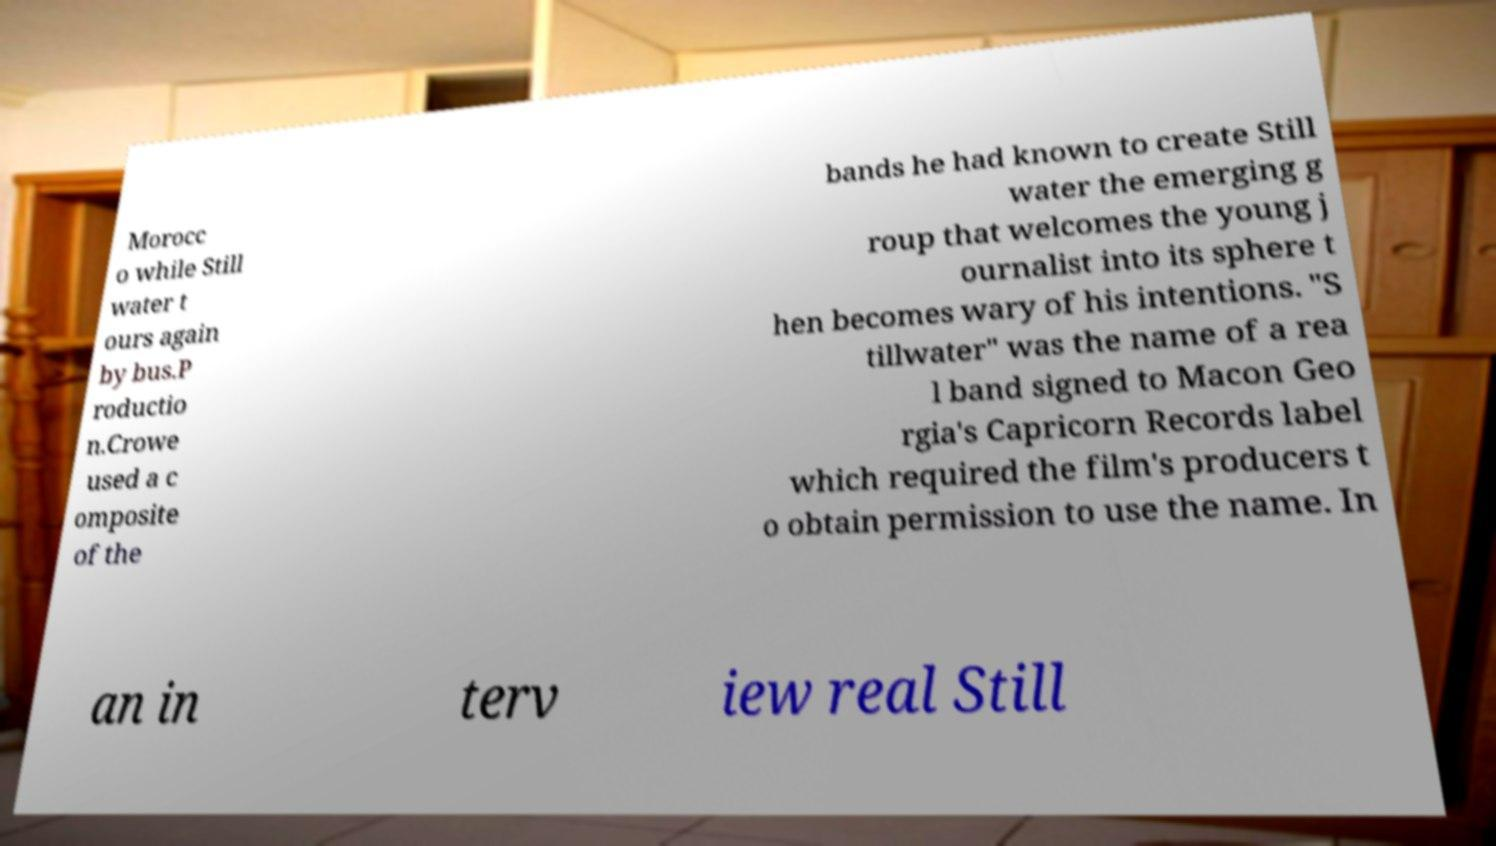Can you read and provide the text displayed in the image?This photo seems to have some interesting text. Can you extract and type it out for me? Morocc o while Still water t ours again by bus.P roductio n.Crowe used a c omposite of the bands he had known to create Still water the emerging g roup that welcomes the young j ournalist into its sphere t hen becomes wary of his intentions. "S tillwater" was the name of a rea l band signed to Macon Geo rgia's Capricorn Records label which required the film's producers t o obtain permission to use the name. In an in terv iew real Still 